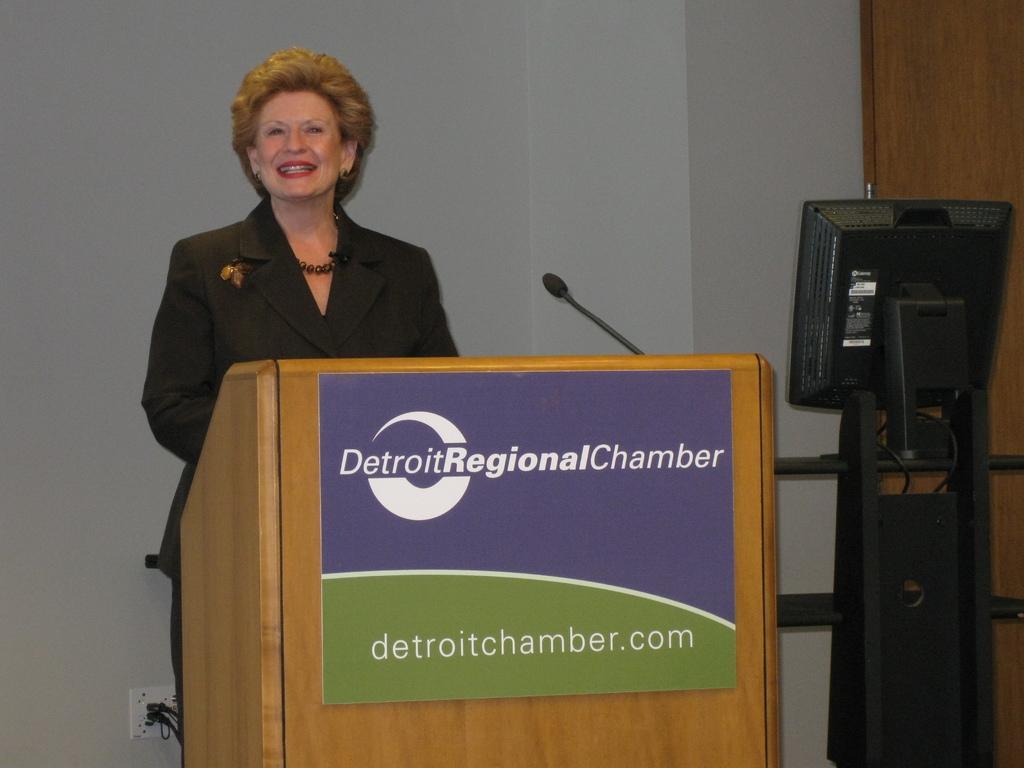Could you give a brief overview of what you see in this image? In this image I can see a woman is standing. On the right side, I can see a computer. 